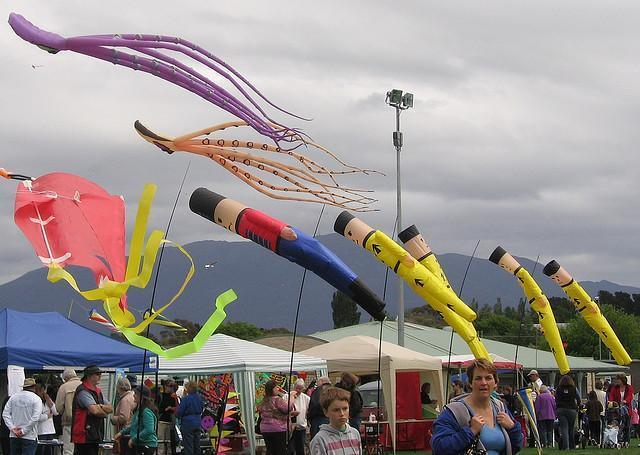How many of the kites are identical?
Give a very brief answer. 4. How many people are in the picture?
Give a very brief answer. 4. How many kites can you see?
Give a very brief answer. 7. How many trains do you see?
Give a very brief answer. 0. 